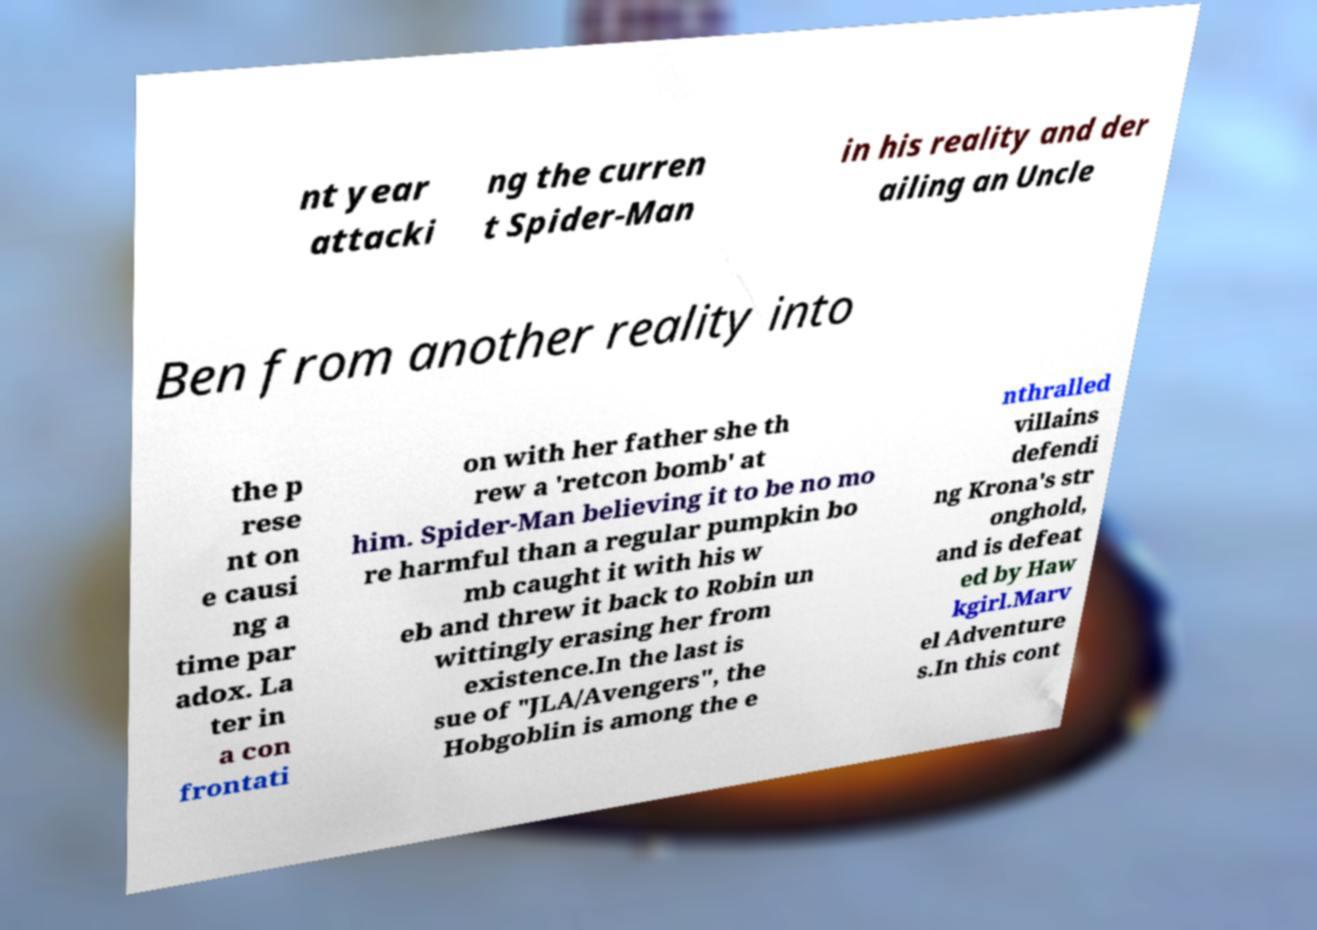For documentation purposes, I need the text within this image transcribed. Could you provide that? nt year attacki ng the curren t Spider-Man in his reality and der ailing an Uncle Ben from another reality into the p rese nt on e causi ng a time par adox. La ter in a con frontati on with her father she th rew a 'retcon bomb' at him. Spider-Man believing it to be no mo re harmful than a regular pumpkin bo mb caught it with his w eb and threw it back to Robin un wittingly erasing her from existence.In the last is sue of "JLA/Avengers", the Hobgoblin is among the e nthralled villains defendi ng Krona's str onghold, and is defeat ed by Haw kgirl.Marv el Adventure s.In this cont 